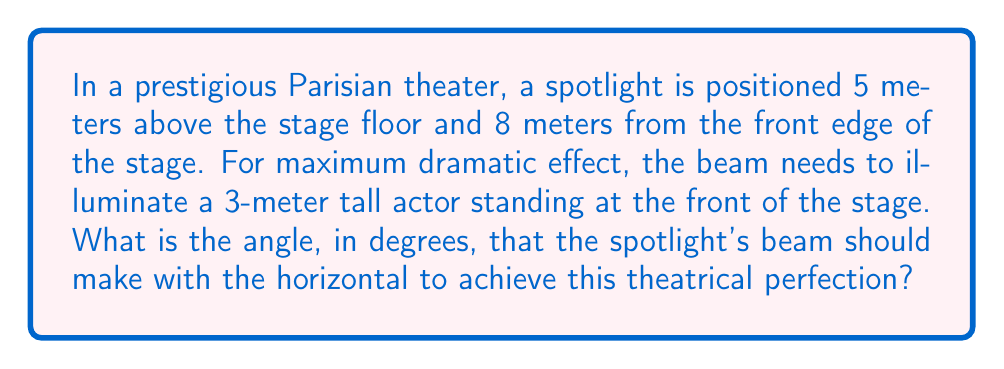What is the answer to this math problem? Let's approach this problem step-by-step:

1) First, let's visualize the scenario:

[asy]
unitsize(0.5cm);
pair A = (0,0), B = (8,0), C = (8,5), D = (0,3);
draw(A--B--C--A--D);
draw(C--D,dashed);
label("Stage", (4,-0.5));
label("Spotlight", C, NE);
label("Actor", D, W);
label("5m", (8.5,2.5));
label("8m", (4,-0.5));
label("3m", (-0.5,1.5));
label("θ", (7.8,4.7), NW);
[/asy]

2) We can see that this forms a right-angled triangle. We need to find the angle θ.

3) The vertical distance between the spotlight and the top of the actor is:
   $5m - 3m = 2m$

4) We now have a right-angled triangle with:
   - Adjacent side (horizontal distance) = 8m
   - Opposite side (vertical distance) = 2m

5) To find the angle, we can use the tangent function:

   $$\tan(\theta) = \frac{\text{opposite}}{\text{adjacent}} = \frac{2}{8} = \frac{1}{4}$$

6) To get θ, we need to use the inverse tangent (arctan or $\tan^{-1}$):

   $$\theta = \tan^{-1}(\frac{1}{4})$$

7) Using a calculator or computer:

   $$\theta \approx 14.0362^\circ$$

8) Rounding to two decimal places for practical use in theater:

   $$\theta \approx 14.04^\circ$$
Answer: $14.04^\circ$ 